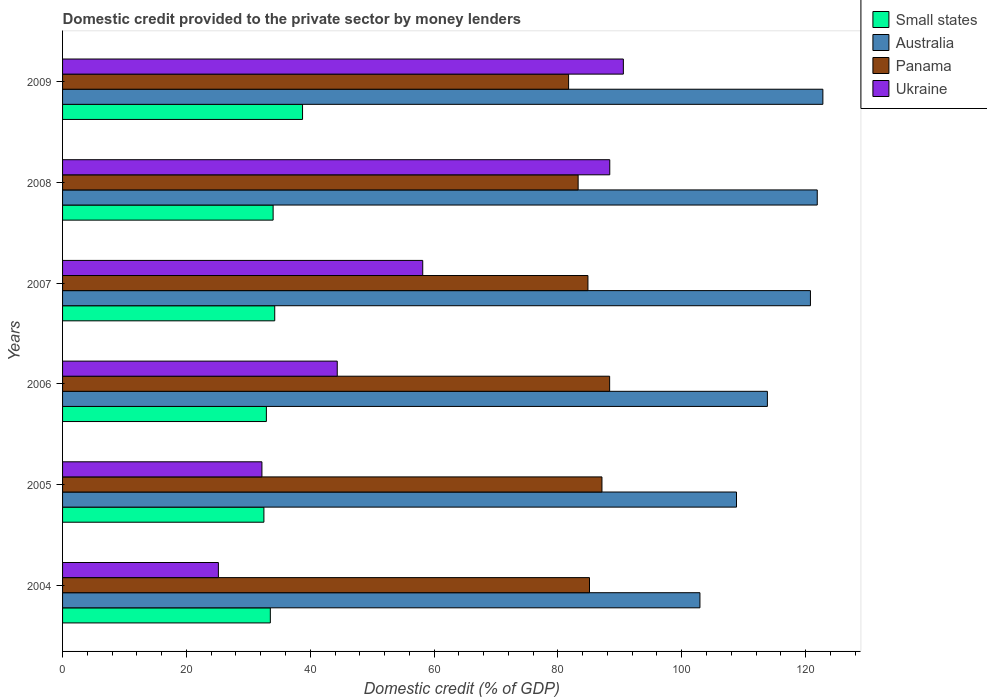How many different coloured bars are there?
Keep it short and to the point. 4. How many groups of bars are there?
Give a very brief answer. 6. Are the number of bars per tick equal to the number of legend labels?
Your answer should be very brief. Yes. How many bars are there on the 5th tick from the top?
Your answer should be very brief. 4. What is the label of the 2nd group of bars from the top?
Keep it short and to the point. 2008. In how many cases, is the number of bars for a given year not equal to the number of legend labels?
Your response must be concise. 0. What is the domestic credit provided to the private sector by money lenders in Panama in 2008?
Your response must be concise. 83.27. Across all years, what is the maximum domestic credit provided to the private sector by money lenders in Panama?
Keep it short and to the point. 88.36. Across all years, what is the minimum domestic credit provided to the private sector by money lenders in Small states?
Your response must be concise. 32.52. In which year was the domestic credit provided to the private sector by money lenders in Ukraine maximum?
Ensure brevity in your answer.  2009. In which year was the domestic credit provided to the private sector by money lenders in Australia minimum?
Offer a terse response. 2004. What is the total domestic credit provided to the private sector by money lenders in Ukraine in the graph?
Offer a very short reply. 338.85. What is the difference between the domestic credit provided to the private sector by money lenders in Small states in 2005 and that in 2008?
Offer a terse response. -1.49. What is the difference between the domestic credit provided to the private sector by money lenders in Small states in 2004 and the domestic credit provided to the private sector by money lenders in Panama in 2007?
Offer a very short reply. -51.3. What is the average domestic credit provided to the private sector by money lenders in Australia per year?
Offer a terse response. 115.18. In the year 2004, what is the difference between the domestic credit provided to the private sector by money lenders in Ukraine and domestic credit provided to the private sector by money lenders in Panama?
Your answer should be compact. -59.94. What is the ratio of the domestic credit provided to the private sector by money lenders in Small states in 2007 to that in 2008?
Offer a very short reply. 1.01. Is the domestic credit provided to the private sector by money lenders in Ukraine in 2006 less than that in 2007?
Give a very brief answer. Yes. Is the difference between the domestic credit provided to the private sector by money lenders in Ukraine in 2004 and 2009 greater than the difference between the domestic credit provided to the private sector by money lenders in Panama in 2004 and 2009?
Give a very brief answer. No. What is the difference between the highest and the second highest domestic credit provided to the private sector by money lenders in Small states?
Make the answer very short. 4.49. What is the difference between the highest and the lowest domestic credit provided to the private sector by money lenders in Panama?
Provide a succinct answer. 6.63. Is the sum of the domestic credit provided to the private sector by money lenders in Panama in 2006 and 2007 greater than the maximum domestic credit provided to the private sector by money lenders in Australia across all years?
Give a very brief answer. Yes. What does the 4th bar from the top in 2004 represents?
Your answer should be compact. Small states. What does the 4th bar from the bottom in 2008 represents?
Your answer should be compact. Ukraine. Is it the case that in every year, the sum of the domestic credit provided to the private sector by money lenders in Ukraine and domestic credit provided to the private sector by money lenders in Australia is greater than the domestic credit provided to the private sector by money lenders in Small states?
Your answer should be compact. Yes. Are all the bars in the graph horizontal?
Offer a very short reply. Yes. How many years are there in the graph?
Offer a terse response. 6. What is the difference between two consecutive major ticks on the X-axis?
Your answer should be very brief. 20. How many legend labels are there?
Provide a succinct answer. 4. What is the title of the graph?
Make the answer very short. Domestic credit provided to the private sector by money lenders. Does "European Union" appear as one of the legend labels in the graph?
Make the answer very short. No. What is the label or title of the X-axis?
Give a very brief answer. Domestic credit (% of GDP). What is the label or title of the Y-axis?
Provide a succinct answer. Years. What is the Domestic credit (% of GDP) in Small states in 2004?
Keep it short and to the point. 33.56. What is the Domestic credit (% of GDP) of Australia in 2004?
Offer a terse response. 102.94. What is the Domestic credit (% of GDP) of Panama in 2004?
Provide a short and direct response. 85.11. What is the Domestic credit (% of GDP) in Ukraine in 2004?
Your answer should be very brief. 25.17. What is the Domestic credit (% of GDP) of Small states in 2005?
Provide a short and direct response. 32.52. What is the Domestic credit (% of GDP) of Australia in 2005?
Offer a very short reply. 108.85. What is the Domestic credit (% of GDP) in Panama in 2005?
Provide a succinct answer. 87.12. What is the Domestic credit (% of GDP) in Ukraine in 2005?
Make the answer very short. 32.2. What is the Domestic credit (% of GDP) in Small states in 2006?
Provide a succinct answer. 32.92. What is the Domestic credit (% of GDP) of Australia in 2006?
Ensure brevity in your answer.  113.84. What is the Domestic credit (% of GDP) of Panama in 2006?
Make the answer very short. 88.36. What is the Domestic credit (% of GDP) in Ukraine in 2006?
Offer a terse response. 44.36. What is the Domestic credit (% of GDP) in Small states in 2007?
Offer a very short reply. 34.27. What is the Domestic credit (% of GDP) of Australia in 2007?
Give a very brief answer. 120.79. What is the Domestic credit (% of GDP) in Panama in 2007?
Keep it short and to the point. 84.85. What is the Domestic credit (% of GDP) in Ukraine in 2007?
Provide a short and direct response. 58.17. What is the Domestic credit (% of GDP) in Small states in 2008?
Your response must be concise. 34.01. What is the Domestic credit (% of GDP) in Australia in 2008?
Your answer should be compact. 121.89. What is the Domestic credit (% of GDP) of Panama in 2008?
Make the answer very short. 83.27. What is the Domestic credit (% of GDP) in Ukraine in 2008?
Your response must be concise. 88.38. What is the Domestic credit (% of GDP) of Small states in 2009?
Provide a succinct answer. 38.76. What is the Domestic credit (% of GDP) in Australia in 2009?
Your answer should be compact. 122.8. What is the Domestic credit (% of GDP) of Panama in 2009?
Offer a terse response. 81.73. What is the Domestic credit (% of GDP) in Ukraine in 2009?
Make the answer very short. 90.57. Across all years, what is the maximum Domestic credit (% of GDP) of Small states?
Offer a terse response. 38.76. Across all years, what is the maximum Domestic credit (% of GDP) of Australia?
Your answer should be compact. 122.8. Across all years, what is the maximum Domestic credit (% of GDP) of Panama?
Your response must be concise. 88.36. Across all years, what is the maximum Domestic credit (% of GDP) of Ukraine?
Your answer should be compact. 90.57. Across all years, what is the minimum Domestic credit (% of GDP) in Small states?
Give a very brief answer. 32.52. Across all years, what is the minimum Domestic credit (% of GDP) in Australia?
Your answer should be compact. 102.94. Across all years, what is the minimum Domestic credit (% of GDP) of Panama?
Your answer should be compact. 81.73. Across all years, what is the minimum Domestic credit (% of GDP) of Ukraine?
Your answer should be compact. 25.17. What is the total Domestic credit (% of GDP) of Small states in the graph?
Ensure brevity in your answer.  206.03. What is the total Domestic credit (% of GDP) in Australia in the graph?
Provide a succinct answer. 691.1. What is the total Domestic credit (% of GDP) in Panama in the graph?
Keep it short and to the point. 510.43. What is the total Domestic credit (% of GDP) in Ukraine in the graph?
Offer a terse response. 338.85. What is the difference between the Domestic credit (% of GDP) in Small states in 2004 and that in 2005?
Offer a terse response. 1.04. What is the difference between the Domestic credit (% of GDP) of Australia in 2004 and that in 2005?
Offer a very short reply. -5.91. What is the difference between the Domestic credit (% of GDP) in Panama in 2004 and that in 2005?
Provide a succinct answer. -2.01. What is the difference between the Domestic credit (% of GDP) of Ukraine in 2004 and that in 2005?
Make the answer very short. -7.03. What is the difference between the Domestic credit (% of GDP) of Small states in 2004 and that in 2006?
Provide a succinct answer. 0.64. What is the difference between the Domestic credit (% of GDP) in Australia in 2004 and that in 2006?
Offer a terse response. -10.89. What is the difference between the Domestic credit (% of GDP) in Panama in 2004 and that in 2006?
Make the answer very short. -3.25. What is the difference between the Domestic credit (% of GDP) of Ukraine in 2004 and that in 2006?
Offer a very short reply. -19.2. What is the difference between the Domestic credit (% of GDP) of Small states in 2004 and that in 2007?
Your answer should be compact. -0.71. What is the difference between the Domestic credit (% of GDP) in Australia in 2004 and that in 2007?
Your answer should be compact. -17.85. What is the difference between the Domestic credit (% of GDP) of Panama in 2004 and that in 2007?
Your response must be concise. 0.25. What is the difference between the Domestic credit (% of GDP) of Ukraine in 2004 and that in 2007?
Ensure brevity in your answer.  -33. What is the difference between the Domestic credit (% of GDP) of Small states in 2004 and that in 2008?
Offer a terse response. -0.45. What is the difference between the Domestic credit (% of GDP) of Australia in 2004 and that in 2008?
Keep it short and to the point. -18.95. What is the difference between the Domestic credit (% of GDP) of Panama in 2004 and that in 2008?
Ensure brevity in your answer.  1.84. What is the difference between the Domestic credit (% of GDP) in Ukraine in 2004 and that in 2008?
Provide a short and direct response. -63.21. What is the difference between the Domestic credit (% of GDP) of Small states in 2004 and that in 2009?
Make the answer very short. -5.2. What is the difference between the Domestic credit (% of GDP) of Australia in 2004 and that in 2009?
Provide a short and direct response. -19.86. What is the difference between the Domestic credit (% of GDP) in Panama in 2004 and that in 2009?
Make the answer very short. 3.38. What is the difference between the Domestic credit (% of GDP) of Ukraine in 2004 and that in 2009?
Your answer should be very brief. -65.41. What is the difference between the Domestic credit (% of GDP) of Small states in 2005 and that in 2006?
Make the answer very short. -0.4. What is the difference between the Domestic credit (% of GDP) of Australia in 2005 and that in 2006?
Ensure brevity in your answer.  -4.99. What is the difference between the Domestic credit (% of GDP) in Panama in 2005 and that in 2006?
Provide a succinct answer. -1.24. What is the difference between the Domestic credit (% of GDP) of Ukraine in 2005 and that in 2006?
Your response must be concise. -12.17. What is the difference between the Domestic credit (% of GDP) of Small states in 2005 and that in 2007?
Provide a succinct answer. -1.75. What is the difference between the Domestic credit (% of GDP) in Australia in 2005 and that in 2007?
Make the answer very short. -11.94. What is the difference between the Domestic credit (% of GDP) of Panama in 2005 and that in 2007?
Your answer should be very brief. 2.26. What is the difference between the Domestic credit (% of GDP) in Ukraine in 2005 and that in 2007?
Ensure brevity in your answer.  -25.97. What is the difference between the Domestic credit (% of GDP) in Small states in 2005 and that in 2008?
Ensure brevity in your answer.  -1.49. What is the difference between the Domestic credit (% of GDP) of Australia in 2005 and that in 2008?
Provide a short and direct response. -13.04. What is the difference between the Domestic credit (% of GDP) of Panama in 2005 and that in 2008?
Ensure brevity in your answer.  3.85. What is the difference between the Domestic credit (% of GDP) in Ukraine in 2005 and that in 2008?
Your answer should be compact. -56.18. What is the difference between the Domestic credit (% of GDP) in Small states in 2005 and that in 2009?
Your answer should be compact. -6.24. What is the difference between the Domestic credit (% of GDP) in Australia in 2005 and that in 2009?
Make the answer very short. -13.95. What is the difference between the Domestic credit (% of GDP) of Panama in 2005 and that in 2009?
Offer a very short reply. 5.39. What is the difference between the Domestic credit (% of GDP) in Ukraine in 2005 and that in 2009?
Give a very brief answer. -58.38. What is the difference between the Domestic credit (% of GDP) of Small states in 2006 and that in 2007?
Offer a terse response. -1.35. What is the difference between the Domestic credit (% of GDP) of Australia in 2006 and that in 2007?
Offer a very short reply. -6.95. What is the difference between the Domestic credit (% of GDP) of Panama in 2006 and that in 2007?
Provide a short and direct response. 3.51. What is the difference between the Domestic credit (% of GDP) in Ukraine in 2006 and that in 2007?
Offer a terse response. -13.81. What is the difference between the Domestic credit (% of GDP) of Small states in 2006 and that in 2008?
Your response must be concise. -1.09. What is the difference between the Domestic credit (% of GDP) in Australia in 2006 and that in 2008?
Your response must be concise. -8.05. What is the difference between the Domestic credit (% of GDP) in Panama in 2006 and that in 2008?
Provide a short and direct response. 5.09. What is the difference between the Domestic credit (% of GDP) in Ukraine in 2006 and that in 2008?
Your answer should be compact. -44.02. What is the difference between the Domestic credit (% of GDP) in Small states in 2006 and that in 2009?
Your answer should be compact. -5.84. What is the difference between the Domestic credit (% of GDP) in Australia in 2006 and that in 2009?
Offer a very short reply. -8.96. What is the difference between the Domestic credit (% of GDP) of Panama in 2006 and that in 2009?
Offer a very short reply. 6.63. What is the difference between the Domestic credit (% of GDP) of Ukraine in 2006 and that in 2009?
Ensure brevity in your answer.  -46.21. What is the difference between the Domestic credit (% of GDP) in Small states in 2007 and that in 2008?
Offer a very short reply. 0.26. What is the difference between the Domestic credit (% of GDP) of Australia in 2007 and that in 2008?
Your response must be concise. -1.1. What is the difference between the Domestic credit (% of GDP) in Panama in 2007 and that in 2008?
Your response must be concise. 1.58. What is the difference between the Domestic credit (% of GDP) of Ukraine in 2007 and that in 2008?
Ensure brevity in your answer.  -30.21. What is the difference between the Domestic credit (% of GDP) of Small states in 2007 and that in 2009?
Make the answer very short. -4.49. What is the difference between the Domestic credit (% of GDP) in Australia in 2007 and that in 2009?
Provide a succinct answer. -2.01. What is the difference between the Domestic credit (% of GDP) in Panama in 2007 and that in 2009?
Ensure brevity in your answer.  3.12. What is the difference between the Domestic credit (% of GDP) in Ukraine in 2007 and that in 2009?
Ensure brevity in your answer.  -32.4. What is the difference between the Domestic credit (% of GDP) in Small states in 2008 and that in 2009?
Make the answer very short. -4.75. What is the difference between the Domestic credit (% of GDP) in Australia in 2008 and that in 2009?
Provide a short and direct response. -0.91. What is the difference between the Domestic credit (% of GDP) of Panama in 2008 and that in 2009?
Offer a terse response. 1.54. What is the difference between the Domestic credit (% of GDP) of Ukraine in 2008 and that in 2009?
Provide a succinct answer. -2.19. What is the difference between the Domestic credit (% of GDP) of Small states in 2004 and the Domestic credit (% of GDP) of Australia in 2005?
Your answer should be very brief. -75.29. What is the difference between the Domestic credit (% of GDP) of Small states in 2004 and the Domestic credit (% of GDP) of Panama in 2005?
Offer a very short reply. -53.56. What is the difference between the Domestic credit (% of GDP) of Small states in 2004 and the Domestic credit (% of GDP) of Ukraine in 2005?
Your answer should be compact. 1.36. What is the difference between the Domestic credit (% of GDP) of Australia in 2004 and the Domestic credit (% of GDP) of Panama in 2005?
Your answer should be very brief. 15.82. What is the difference between the Domestic credit (% of GDP) of Australia in 2004 and the Domestic credit (% of GDP) of Ukraine in 2005?
Your response must be concise. 70.74. What is the difference between the Domestic credit (% of GDP) in Panama in 2004 and the Domestic credit (% of GDP) in Ukraine in 2005?
Provide a short and direct response. 52.91. What is the difference between the Domestic credit (% of GDP) of Small states in 2004 and the Domestic credit (% of GDP) of Australia in 2006?
Keep it short and to the point. -80.28. What is the difference between the Domestic credit (% of GDP) in Small states in 2004 and the Domestic credit (% of GDP) in Panama in 2006?
Ensure brevity in your answer.  -54.8. What is the difference between the Domestic credit (% of GDP) in Small states in 2004 and the Domestic credit (% of GDP) in Ukraine in 2006?
Ensure brevity in your answer.  -10.81. What is the difference between the Domestic credit (% of GDP) in Australia in 2004 and the Domestic credit (% of GDP) in Panama in 2006?
Your answer should be compact. 14.58. What is the difference between the Domestic credit (% of GDP) of Australia in 2004 and the Domestic credit (% of GDP) of Ukraine in 2006?
Offer a terse response. 58.58. What is the difference between the Domestic credit (% of GDP) of Panama in 2004 and the Domestic credit (% of GDP) of Ukraine in 2006?
Keep it short and to the point. 40.74. What is the difference between the Domestic credit (% of GDP) in Small states in 2004 and the Domestic credit (% of GDP) in Australia in 2007?
Provide a succinct answer. -87.23. What is the difference between the Domestic credit (% of GDP) in Small states in 2004 and the Domestic credit (% of GDP) in Panama in 2007?
Provide a succinct answer. -51.3. What is the difference between the Domestic credit (% of GDP) of Small states in 2004 and the Domestic credit (% of GDP) of Ukraine in 2007?
Make the answer very short. -24.61. What is the difference between the Domestic credit (% of GDP) of Australia in 2004 and the Domestic credit (% of GDP) of Panama in 2007?
Provide a succinct answer. 18.09. What is the difference between the Domestic credit (% of GDP) of Australia in 2004 and the Domestic credit (% of GDP) of Ukraine in 2007?
Provide a succinct answer. 44.77. What is the difference between the Domestic credit (% of GDP) in Panama in 2004 and the Domestic credit (% of GDP) in Ukraine in 2007?
Your response must be concise. 26.94. What is the difference between the Domestic credit (% of GDP) of Small states in 2004 and the Domestic credit (% of GDP) of Australia in 2008?
Your answer should be compact. -88.33. What is the difference between the Domestic credit (% of GDP) in Small states in 2004 and the Domestic credit (% of GDP) in Panama in 2008?
Provide a succinct answer. -49.71. What is the difference between the Domestic credit (% of GDP) of Small states in 2004 and the Domestic credit (% of GDP) of Ukraine in 2008?
Your answer should be compact. -54.82. What is the difference between the Domestic credit (% of GDP) in Australia in 2004 and the Domestic credit (% of GDP) in Panama in 2008?
Your answer should be very brief. 19.67. What is the difference between the Domestic credit (% of GDP) in Australia in 2004 and the Domestic credit (% of GDP) in Ukraine in 2008?
Your answer should be very brief. 14.56. What is the difference between the Domestic credit (% of GDP) of Panama in 2004 and the Domestic credit (% of GDP) of Ukraine in 2008?
Your answer should be very brief. -3.27. What is the difference between the Domestic credit (% of GDP) in Small states in 2004 and the Domestic credit (% of GDP) in Australia in 2009?
Make the answer very short. -89.24. What is the difference between the Domestic credit (% of GDP) in Small states in 2004 and the Domestic credit (% of GDP) in Panama in 2009?
Your response must be concise. -48.17. What is the difference between the Domestic credit (% of GDP) of Small states in 2004 and the Domestic credit (% of GDP) of Ukraine in 2009?
Your answer should be very brief. -57.02. What is the difference between the Domestic credit (% of GDP) in Australia in 2004 and the Domestic credit (% of GDP) in Panama in 2009?
Your answer should be compact. 21.21. What is the difference between the Domestic credit (% of GDP) of Australia in 2004 and the Domestic credit (% of GDP) of Ukraine in 2009?
Ensure brevity in your answer.  12.37. What is the difference between the Domestic credit (% of GDP) of Panama in 2004 and the Domestic credit (% of GDP) of Ukraine in 2009?
Offer a terse response. -5.47. What is the difference between the Domestic credit (% of GDP) in Small states in 2005 and the Domestic credit (% of GDP) in Australia in 2006?
Keep it short and to the point. -81.32. What is the difference between the Domestic credit (% of GDP) in Small states in 2005 and the Domestic credit (% of GDP) in Panama in 2006?
Provide a short and direct response. -55.84. What is the difference between the Domestic credit (% of GDP) of Small states in 2005 and the Domestic credit (% of GDP) of Ukraine in 2006?
Give a very brief answer. -11.84. What is the difference between the Domestic credit (% of GDP) of Australia in 2005 and the Domestic credit (% of GDP) of Panama in 2006?
Provide a short and direct response. 20.49. What is the difference between the Domestic credit (% of GDP) in Australia in 2005 and the Domestic credit (% of GDP) in Ukraine in 2006?
Make the answer very short. 64.48. What is the difference between the Domestic credit (% of GDP) in Panama in 2005 and the Domestic credit (% of GDP) in Ukraine in 2006?
Your response must be concise. 42.75. What is the difference between the Domestic credit (% of GDP) of Small states in 2005 and the Domestic credit (% of GDP) of Australia in 2007?
Offer a terse response. -88.27. What is the difference between the Domestic credit (% of GDP) of Small states in 2005 and the Domestic credit (% of GDP) of Panama in 2007?
Keep it short and to the point. -52.33. What is the difference between the Domestic credit (% of GDP) in Small states in 2005 and the Domestic credit (% of GDP) in Ukraine in 2007?
Offer a terse response. -25.65. What is the difference between the Domestic credit (% of GDP) of Australia in 2005 and the Domestic credit (% of GDP) of Panama in 2007?
Your answer should be compact. 23.99. What is the difference between the Domestic credit (% of GDP) in Australia in 2005 and the Domestic credit (% of GDP) in Ukraine in 2007?
Offer a very short reply. 50.68. What is the difference between the Domestic credit (% of GDP) in Panama in 2005 and the Domestic credit (% of GDP) in Ukraine in 2007?
Ensure brevity in your answer.  28.95. What is the difference between the Domestic credit (% of GDP) of Small states in 2005 and the Domestic credit (% of GDP) of Australia in 2008?
Your response must be concise. -89.37. What is the difference between the Domestic credit (% of GDP) in Small states in 2005 and the Domestic credit (% of GDP) in Panama in 2008?
Offer a very short reply. -50.75. What is the difference between the Domestic credit (% of GDP) of Small states in 2005 and the Domestic credit (% of GDP) of Ukraine in 2008?
Ensure brevity in your answer.  -55.86. What is the difference between the Domestic credit (% of GDP) of Australia in 2005 and the Domestic credit (% of GDP) of Panama in 2008?
Keep it short and to the point. 25.58. What is the difference between the Domestic credit (% of GDP) in Australia in 2005 and the Domestic credit (% of GDP) in Ukraine in 2008?
Give a very brief answer. 20.47. What is the difference between the Domestic credit (% of GDP) of Panama in 2005 and the Domestic credit (% of GDP) of Ukraine in 2008?
Give a very brief answer. -1.26. What is the difference between the Domestic credit (% of GDP) of Small states in 2005 and the Domestic credit (% of GDP) of Australia in 2009?
Ensure brevity in your answer.  -90.28. What is the difference between the Domestic credit (% of GDP) in Small states in 2005 and the Domestic credit (% of GDP) in Panama in 2009?
Keep it short and to the point. -49.21. What is the difference between the Domestic credit (% of GDP) of Small states in 2005 and the Domestic credit (% of GDP) of Ukraine in 2009?
Offer a very short reply. -58.05. What is the difference between the Domestic credit (% of GDP) of Australia in 2005 and the Domestic credit (% of GDP) of Panama in 2009?
Offer a very short reply. 27.12. What is the difference between the Domestic credit (% of GDP) of Australia in 2005 and the Domestic credit (% of GDP) of Ukraine in 2009?
Keep it short and to the point. 18.27. What is the difference between the Domestic credit (% of GDP) of Panama in 2005 and the Domestic credit (% of GDP) of Ukraine in 2009?
Offer a very short reply. -3.46. What is the difference between the Domestic credit (% of GDP) of Small states in 2006 and the Domestic credit (% of GDP) of Australia in 2007?
Provide a succinct answer. -87.87. What is the difference between the Domestic credit (% of GDP) in Small states in 2006 and the Domestic credit (% of GDP) in Panama in 2007?
Your answer should be very brief. -51.94. What is the difference between the Domestic credit (% of GDP) of Small states in 2006 and the Domestic credit (% of GDP) of Ukraine in 2007?
Your answer should be very brief. -25.25. What is the difference between the Domestic credit (% of GDP) of Australia in 2006 and the Domestic credit (% of GDP) of Panama in 2007?
Ensure brevity in your answer.  28.98. What is the difference between the Domestic credit (% of GDP) in Australia in 2006 and the Domestic credit (% of GDP) in Ukraine in 2007?
Ensure brevity in your answer.  55.67. What is the difference between the Domestic credit (% of GDP) in Panama in 2006 and the Domestic credit (% of GDP) in Ukraine in 2007?
Provide a succinct answer. 30.19. What is the difference between the Domestic credit (% of GDP) of Small states in 2006 and the Domestic credit (% of GDP) of Australia in 2008?
Offer a terse response. -88.97. What is the difference between the Domestic credit (% of GDP) of Small states in 2006 and the Domestic credit (% of GDP) of Panama in 2008?
Offer a very short reply. -50.35. What is the difference between the Domestic credit (% of GDP) in Small states in 2006 and the Domestic credit (% of GDP) in Ukraine in 2008?
Offer a terse response. -55.46. What is the difference between the Domestic credit (% of GDP) in Australia in 2006 and the Domestic credit (% of GDP) in Panama in 2008?
Keep it short and to the point. 30.57. What is the difference between the Domestic credit (% of GDP) of Australia in 2006 and the Domestic credit (% of GDP) of Ukraine in 2008?
Make the answer very short. 25.46. What is the difference between the Domestic credit (% of GDP) of Panama in 2006 and the Domestic credit (% of GDP) of Ukraine in 2008?
Your response must be concise. -0.02. What is the difference between the Domestic credit (% of GDP) of Small states in 2006 and the Domestic credit (% of GDP) of Australia in 2009?
Your response must be concise. -89.88. What is the difference between the Domestic credit (% of GDP) in Small states in 2006 and the Domestic credit (% of GDP) in Panama in 2009?
Offer a terse response. -48.81. What is the difference between the Domestic credit (% of GDP) of Small states in 2006 and the Domestic credit (% of GDP) of Ukraine in 2009?
Offer a terse response. -57.66. What is the difference between the Domestic credit (% of GDP) of Australia in 2006 and the Domestic credit (% of GDP) of Panama in 2009?
Provide a short and direct response. 32.11. What is the difference between the Domestic credit (% of GDP) of Australia in 2006 and the Domestic credit (% of GDP) of Ukraine in 2009?
Keep it short and to the point. 23.26. What is the difference between the Domestic credit (% of GDP) of Panama in 2006 and the Domestic credit (% of GDP) of Ukraine in 2009?
Offer a terse response. -2.21. What is the difference between the Domestic credit (% of GDP) of Small states in 2007 and the Domestic credit (% of GDP) of Australia in 2008?
Make the answer very short. -87.62. What is the difference between the Domestic credit (% of GDP) of Small states in 2007 and the Domestic credit (% of GDP) of Panama in 2008?
Provide a short and direct response. -49. What is the difference between the Domestic credit (% of GDP) in Small states in 2007 and the Domestic credit (% of GDP) in Ukraine in 2008?
Your answer should be compact. -54.11. What is the difference between the Domestic credit (% of GDP) of Australia in 2007 and the Domestic credit (% of GDP) of Panama in 2008?
Your response must be concise. 37.52. What is the difference between the Domestic credit (% of GDP) of Australia in 2007 and the Domestic credit (% of GDP) of Ukraine in 2008?
Ensure brevity in your answer.  32.41. What is the difference between the Domestic credit (% of GDP) of Panama in 2007 and the Domestic credit (% of GDP) of Ukraine in 2008?
Make the answer very short. -3.53. What is the difference between the Domestic credit (% of GDP) of Small states in 2007 and the Domestic credit (% of GDP) of Australia in 2009?
Your answer should be very brief. -88.53. What is the difference between the Domestic credit (% of GDP) of Small states in 2007 and the Domestic credit (% of GDP) of Panama in 2009?
Ensure brevity in your answer.  -47.46. What is the difference between the Domestic credit (% of GDP) in Small states in 2007 and the Domestic credit (% of GDP) in Ukraine in 2009?
Offer a terse response. -56.31. What is the difference between the Domestic credit (% of GDP) of Australia in 2007 and the Domestic credit (% of GDP) of Panama in 2009?
Provide a succinct answer. 39.06. What is the difference between the Domestic credit (% of GDP) in Australia in 2007 and the Domestic credit (% of GDP) in Ukraine in 2009?
Provide a succinct answer. 30.22. What is the difference between the Domestic credit (% of GDP) in Panama in 2007 and the Domestic credit (% of GDP) in Ukraine in 2009?
Ensure brevity in your answer.  -5.72. What is the difference between the Domestic credit (% of GDP) of Small states in 2008 and the Domestic credit (% of GDP) of Australia in 2009?
Your answer should be compact. -88.79. What is the difference between the Domestic credit (% of GDP) of Small states in 2008 and the Domestic credit (% of GDP) of Panama in 2009?
Your response must be concise. -47.72. What is the difference between the Domestic credit (% of GDP) in Small states in 2008 and the Domestic credit (% of GDP) in Ukraine in 2009?
Offer a terse response. -56.57. What is the difference between the Domestic credit (% of GDP) of Australia in 2008 and the Domestic credit (% of GDP) of Panama in 2009?
Give a very brief answer. 40.16. What is the difference between the Domestic credit (% of GDP) in Australia in 2008 and the Domestic credit (% of GDP) in Ukraine in 2009?
Provide a short and direct response. 31.32. What is the difference between the Domestic credit (% of GDP) in Panama in 2008 and the Domestic credit (% of GDP) in Ukraine in 2009?
Offer a terse response. -7.3. What is the average Domestic credit (% of GDP) of Small states per year?
Provide a succinct answer. 34.34. What is the average Domestic credit (% of GDP) in Australia per year?
Keep it short and to the point. 115.18. What is the average Domestic credit (% of GDP) in Panama per year?
Give a very brief answer. 85.07. What is the average Domestic credit (% of GDP) of Ukraine per year?
Give a very brief answer. 56.47. In the year 2004, what is the difference between the Domestic credit (% of GDP) of Small states and Domestic credit (% of GDP) of Australia?
Provide a succinct answer. -69.38. In the year 2004, what is the difference between the Domestic credit (% of GDP) of Small states and Domestic credit (% of GDP) of Panama?
Your response must be concise. -51.55. In the year 2004, what is the difference between the Domestic credit (% of GDP) in Small states and Domestic credit (% of GDP) in Ukraine?
Your answer should be compact. 8.39. In the year 2004, what is the difference between the Domestic credit (% of GDP) in Australia and Domestic credit (% of GDP) in Panama?
Your response must be concise. 17.84. In the year 2004, what is the difference between the Domestic credit (% of GDP) in Australia and Domestic credit (% of GDP) in Ukraine?
Offer a terse response. 77.77. In the year 2004, what is the difference between the Domestic credit (% of GDP) in Panama and Domestic credit (% of GDP) in Ukraine?
Keep it short and to the point. 59.94. In the year 2005, what is the difference between the Domestic credit (% of GDP) of Small states and Domestic credit (% of GDP) of Australia?
Offer a terse response. -76.33. In the year 2005, what is the difference between the Domestic credit (% of GDP) in Small states and Domestic credit (% of GDP) in Panama?
Make the answer very short. -54.6. In the year 2005, what is the difference between the Domestic credit (% of GDP) of Small states and Domestic credit (% of GDP) of Ukraine?
Make the answer very short. 0.32. In the year 2005, what is the difference between the Domestic credit (% of GDP) of Australia and Domestic credit (% of GDP) of Panama?
Your response must be concise. 21.73. In the year 2005, what is the difference between the Domestic credit (% of GDP) of Australia and Domestic credit (% of GDP) of Ukraine?
Give a very brief answer. 76.65. In the year 2005, what is the difference between the Domestic credit (% of GDP) in Panama and Domestic credit (% of GDP) in Ukraine?
Your answer should be very brief. 54.92. In the year 2006, what is the difference between the Domestic credit (% of GDP) in Small states and Domestic credit (% of GDP) in Australia?
Your answer should be compact. -80.92. In the year 2006, what is the difference between the Domestic credit (% of GDP) in Small states and Domestic credit (% of GDP) in Panama?
Provide a succinct answer. -55.44. In the year 2006, what is the difference between the Domestic credit (% of GDP) of Small states and Domestic credit (% of GDP) of Ukraine?
Offer a terse response. -11.45. In the year 2006, what is the difference between the Domestic credit (% of GDP) in Australia and Domestic credit (% of GDP) in Panama?
Offer a terse response. 25.48. In the year 2006, what is the difference between the Domestic credit (% of GDP) of Australia and Domestic credit (% of GDP) of Ukraine?
Your answer should be very brief. 69.47. In the year 2006, what is the difference between the Domestic credit (% of GDP) of Panama and Domestic credit (% of GDP) of Ukraine?
Your response must be concise. 44. In the year 2007, what is the difference between the Domestic credit (% of GDP) in Small states and Domestic credit (% of GDP) in Australia?
Give a very brief answer. -86.52. In the year 2007, what is the difference between the Domestic credit (% of GDP) in Small states and Domestic credit (% of GDP) in Panama?
Give a very brief answer. -50.59. In the year 2007, what is the difference between the Domestic credit (% of GDP) in Small states and Domestic credit (% of GDP) in Ukraine?
Provide a short and direct response. -23.9. In the year 2007, what is the difference between the Domestic credit (% of GDP) of Australia and Domestic credit (% of GDP) of Panama?
Offer a very short reply. 35.94. In the year 2007, what is the difference between the Domestic credit (% of GDP) in Australia and Domestic credit (% of GDP) in Ukraine?
Your response must be concise. 62.62. In the year 2007, what is the difference between the Domestic credit (% of GDP) in Panama and Domestic credit (% of GDP) in Ukraine?
Provide a succinct answer. 26.68. In the year 2008, what is the difference between the Domestic credit (% of GDP) in Small states and Domestic credit (% of GDP) in Australia?
Ensure brevity in your answer.  -87.88. In the year 2008, what is the difference between the Domestic credit (% of GDP) in Small states and Domestic credit (% of GDP) in Panama?
Ensure brevity in your answer.  -49.26. In the year 2008, what is the difference between the Domestic credit (% of GDP) in Small states and Domestic credit (% of GDP) in Ukraine?
Make the answer very short. -54.37. In the year 2008, what is the difference between the Domestic credit (% of GDP) of Australia and Domestic credit (% of GDP) of Panama?
Offer a very short reply. 38.62. In the year 2008, what is the difference between the Domestic credit (% of GDP) in Australia and Domestic credit (% of GDP) in Ukraine?
Make the answer very short. 33.51. In the year 2008, what is the difference between the Domestic credit (% of GDP) of Panama and Domestic credit (% of GDP) of Ukraine?
Offer a terse response. -5.11. In the year 2009, what is the difference between the Domestic credit (% of GDP) in Small states and Domestic credit (% of GDP) in Australia?
Provide a short and direct response. -84.04. In the year 2009, what is the difference between the Domestic credit (% of GDP) of Small states and Domestic credit (% of GDP) of Panama?
Give a very brief answer. -42.97. In the year 2009, what is the difference between the Domestic credit (% of GDP) in Small states and Domestic credit (% of GDP) in Ukraine?
Give a very brief answer. -51.81. In the year 2009, what is the difference between the Domestic credit (% of GDP) of Australia and Domestic credit (% of GDP) of Panama?
Offer a terse response. 41.07. In the year 2009, what is the difference between the Domestic credit (% of GDP) in Australia and Domestic credit (% of GDP) in Ukraine?
Offer a terse response. 32.23. In the year 2009, what is the difference between the Domestic credit (% of GDP) of Panama and Domestic credit (% of GDP) of Ukraine?
Your answer should be very brief. -8.84. What is the ratio of the Domestic credit (% of GDP) of Small states in 2004 to that in 2005?
Provide a short and direct response. 1.03. What is the ratio of the Domestic credit (% of GDP) in Australia in 2004 to that in 2005?
Ensure brevity in your answer.  0.95. What is the ratio of the Domestic credit (% of GDP) of Panama in 2004 to that in 2005?
Your response must be concise. 0.98. What is the ratio of the Domestic credit (% of GDP) in Ukraine in 2004 to that in 2005?
Provide a short and direct response. 0.78. What is the ratio of the Domestic credit (% of GDP) in Small states in 2004 to that in 2006?
Ensure brevity in your answer.  1.02. What is the ratio of the Domestic credit (% of GDP) of Australia in 2004 to that in 2006?
Your answer should be very brief. 0.9. What is the ratio of the Domestic credit (% of GDP) of Panama in 2004 to that in 2006?
Your response must be concise. 0.96. What is the ratio of the Domestic credit (% of GDP) of Ukraine in 2004 to that in 2006?
Your answer should be compact. 0.57. What is the ratio of the Domestic credit (% of GDP) in Small states in 2004 to that in 2007?
Your response must be concise. 0.98. What is the ratio of the Domestic credit (% of GDP) of Australia in 2004 to that in 2007?
Provide a succinct answer. 0.85. What is the ratio of the Domestic credit (% of GDP) of Panama in 2004 to that in 2007?
Your answer should be very brief. 1. What is the ratio of the Domestic credit (% of GDP) of Ukraine in 2004 to that in 2007?
Provide a short and direct response. 0.43. What is the ratio of the Domestic credit (% of GDP) in Small states in 2004 to that in 2008?
Your answer should be compact. 0.99. What is the ratio of the Domestic credit (% of GDP) of Australia in 2004 to that in 2008?
Keep it short and to the point. 0.84. What is the ratio of the Domestic credit (% of GDP) in Panama in 2004 to that in 2008?
Give a very brief answer. 1.02. What is the ratio of the Domestic credit (% of GDP) in Ukraine in 2004 to that in 2008?
Offer a very short reply. 0.28. What is the ratio of the Domestic credit (% of GDP) in Small states in 2004 to that in 2009?
Provide a succinct answer. 0.87. What is the ratio of the Domestic credit (% of GDP) of Australia in 2004 to that in 2009?
Make the answer very short. 0.84. What is the ratio of the Domestic credit (% of GDP) in Panama in 2004 to that in 2009?
Keep it short and to the point. 1.04. What is the ratio of the Domestic credit (% of GDP) in Ukraine in 2004 to that in 2009?
Provide a succinct answer. 0.28. What is the ratio of the Domestic credit (% of GDP) in Small states in 2005 to that in 2006?
Keep it short and to the point. 0.99. What is the ratio of the Domestic credit (% of GDP) in Australia in 2005 to that in 2006?
Provide a short and direct response. 0.96. What is the ratio of the Domestic credit (% of GDP) of Panama in 2005 to that in 2006?
Give a very brief answer. 0.99. What is the ratio of the Domestic credit (% of GDP) of Ukraine in 2005 to that in 2006?
Provide a succinct answer. 0.73. What is the ratio of the Domestic credit (% of GDP) of Small states in 2005 to that in 2007?
Offer a very short reply. 0.95. What is the ratio of the Domestic credit (% of GDP) in Australia in 2005 to that in 2007?
Ensure brevity in your answer.  0.9. What is the ratio of the Domestic credit (% of GDP) in Panama in 2005 to that in 2007?
Provide a succinct answer. 1.03. What is the ratio of the Domestic credit (% of GDP) in Ukraine in 2005 to that in 2007?
Keep it short and to the point. 0.55. What is the ratio of the Domestic credit (% of GDP) in Small states in 2005 to that in 2008?
Ensure brevity in your answer.  0.96. What is the ratio of the Domestic credit (% of GDP) of Australia in 2005 to that in 2008?
Your response must be concise. 0.89. What is the ratio of the Domestic credit (% of GDP) of Panama in 2005 to that in 2008?
Your answer should be compact. 1.05. What is the ratio of the Domestic credit (% of GDP) in Ukraine in 2005 to that in 2008?
Make the answer very short. 0.36. What is the ratio of the Domestic credit (% of GDP) of Small states in 2005 to that in 2009?
Provide a succinct answer. 0.84. What is the ratio of the Domestic credit (% of GDP) in Australia in 2005 to that in 2009?
Give a very brief answer. 0.89. What is the ratio of the Domestic credit (% of GDP) in Panama in 2005 to that in 2009?
Provide a short and direct response. 1.07. What is the ratio of the Domestic credit (% of GDP) of Ukraine in 2005 to that in 2009?
Provide a short and direct response. 0.36. What is the ratio of the Domestic credit (% of GDP) in Small states in 2006 to that in 2007?
Your answer should be compact. 0.96. What is the ratio of the Domestic credit (% of GDP) in Australia in 2006 to that in 2007?
Your answer should be compact. 0.94. What is the ratio of the Domestic credit (% of GDP) of Panama in 2006 to that in 2007?
Offer a terse response. 1.04. What is the ratio of the Domestic credit (% of GDP) of Ukraine in 2006 to that in 2007?
Your answer should be compact. 0.76. What is the ratio of the Domestic credit (% of GDP) of Small states in 2006 to that in 2008?
Provide a short and direct response. 0.97. What is the ratio of the Domestic credit (% of GDP) of Australia in 2006 to that in 2008?
Your response must be concise. 0.93. What is the ratio of the Domestic credit (% of GDP) of Panama in 2006 to that in 2008?
Keep it short and to the point. 1.06. What is the ratio of the Domestic credit (% of GDP) in Ukraine in 2006 to that in 2008?
Make the answer very short. 0.5. What is the ratio of the Domestic credit (% of GDP) in Small states in 2006 to that in 2009?
Provide a short and direct response. 0.85. What is the ratio of the Domestic credit (% of GDP) of Australia in 2006 to that in 2009?
Give a very brief answer. 0.93. What is the ratio of the Domestic credit (% of GDP) in Panama in 2006 to that in 2009?
Make the answer very short. 1.08. What is the ratio of the Domestic credit (% of GDP) of Ukraine in 2006 to that in 2009?
Offer a terse response. 0.49. What is the ratio of the Domestic credit (% of GDP) in Small states in 2007 to that in 2008?
Keep it short and to the point. 1.01. What is the ratio of the Domestic credit (% of GDP) in Panama in 2007 to that in 2008?
Keep it short and to the point. 1.02. What is the ratio of the Domestic credit (% of GDP) in Ukraine in 2007 to that in 2008?
Your answer should be very brief. 0.66. What is the ratio of the Domestic credit (% of GDP) of Small states in 2007 to that in 2009?
Offer a very short reply. 0.88. What is the ratio of the Domestic credit (% of GDP) in Australia in 2007 to that in 2009?
Make the answer very short. 0.98. What is the ratio of the Domestic credit (% of GDP) in Panama in 2007 to that in 2009?
Provide a short and direct response. 1.04. What is the ratio of the Domestic credit (% of GDP) of Ukraine in 2007 to that in 2009?
Offer a terse response. 0.64. What is the ratio of the Domestic credit (% of GDP) in Small states in 2008 to that in 2009?
Your response must be concise. 0.88. What is the ratio of the Domestic credit (% of GDP) of Panama in 2008 to that in 2009?
Provide a succinct answer. 1.02. What is the ratio of the Domestic credit (% of GDP) in Ukraine in 2008 to that in 2009?
Provide a short and direct response. 0.98. What is the difference between the highest and the second highest Domestic credit (% of GDP) in Small states?
Ensure brevity in your answer.  4.49. What is the difference between the highest and the second highest Domestic credit (% of GDP) in Australia?
Provide a short and direct response. 0.91. What is the difference between the highest and the second highest Domestic credit (% of GDP) of Panama?
Your response must be concise. 1.24. What is the difference between the highest and the second highest Domestic credit (% of GDP) in Ukraine?
Your answer should be very brief. 2.19. What is the difference between the highest and the lowest Domestic credit (% of GDP) in Small states?
Your response must be concise. 6.24. What is the difference between the highest and the lowest Domestic credit (% of GDP) of Australia?
Give a very brief answer. 19.86. What is the difference between the highest and the lowest Domestic credit (% of GDP) of Panama?
Provide a succinct answer. 6.63. What is the difference between the highest and the lowest Domestic credit (% of GDP) of Ukraine?
Offer a terse response. 65.41. 